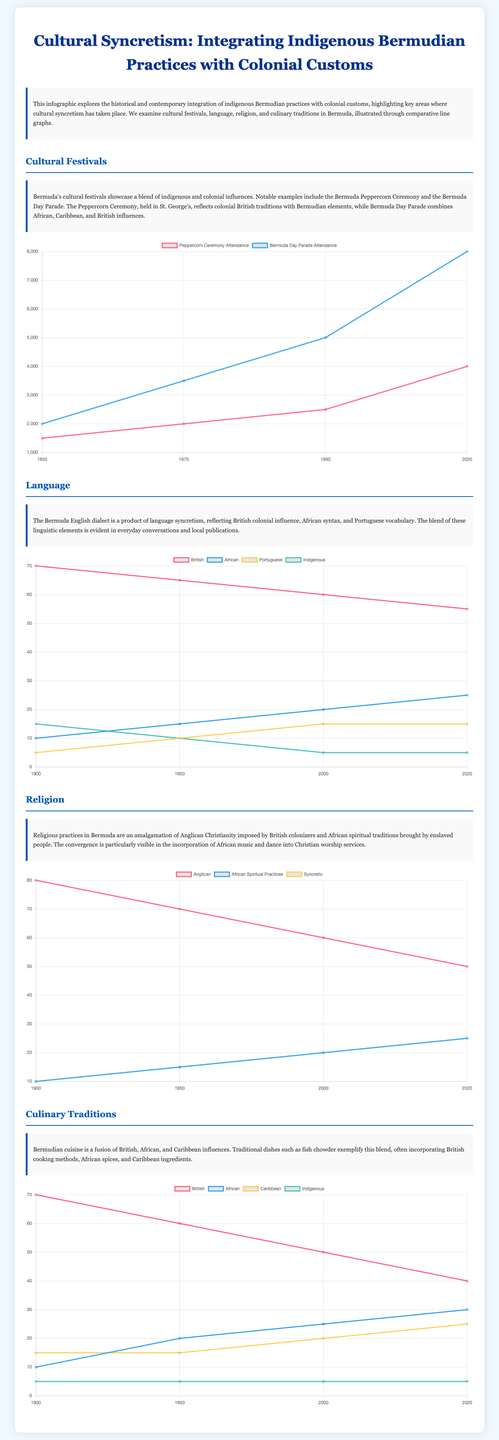What was the attendance for the Peppercorn Ceremony in 2020? The attendance for the Peppercorn Ceremony in 2020 is indicated in the festival attendance chart.
Answer: 4000 What percentage of culinary traditions were influenced by African practices in 2020? The culinary traditions chart shows the percentage of African influences in 2020.
Answer: 30 Which cultural festival had greater attendance growth from 1950 to 2020? The chart compares attendance trends for both festivals over time to identify which saw greater growth.
Answer: Bermuda Day Parade What was the highest percentage of British linguistic usage recorded? The linguistic usage chart provides the percentage of British language usage recorded in the relevant years.
Answer: 70 In what year did Anglican religious adherence decline to 50%? The religious practices chart indicates the year when Anglican adherence dropped to 50%.
Answer: 2020 Which infusion is represented under "Syncretic" in religious practices? The chart categorizes the religious practices including syncretic influences based on the data shown.
Answer: 25 What is the overall trend for indigenous vocabulary usage from 1900 to 2020? The chart indicates the usage trend for indigenous vocabulary over the selected years, indicating a decrease.
Answer: Decrease What is the common theme among the cultural areas analyzed? The infographic presents various cultural aspects showing integration and blending of indigenous and colonial influences overall.
Answer: Cultural Syncretism What year had the lowest attendance for the Bermuda Day Parade? The attendance numbers for Bermuda Day Parade in 1950 is available in the chart, depicting the lowest figure recorded.
Answer: 2000 